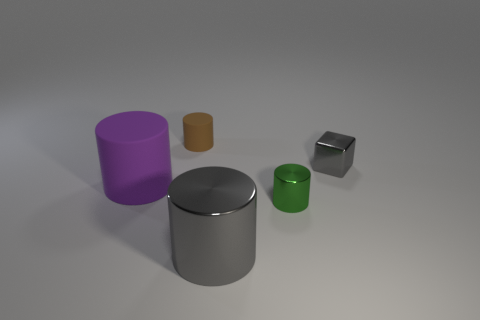Add 1 purple matte cylinders. How many objects exist? 6 Subtract all red cylinders. Subtract all purple blocks. How many cylinders are left? 4 Subtract all blocks. How many objects are left? 4 Add 5 large matte cylinders. How many large matte cylinders exist? 6 Subtract 0 yellow balls. How many objects are left? 5 Subtract all big blue rubber blocks. Subtract all big cylinders. How many objects are left? 3 Add 2 cylinders. How many cylinders are left? 6 